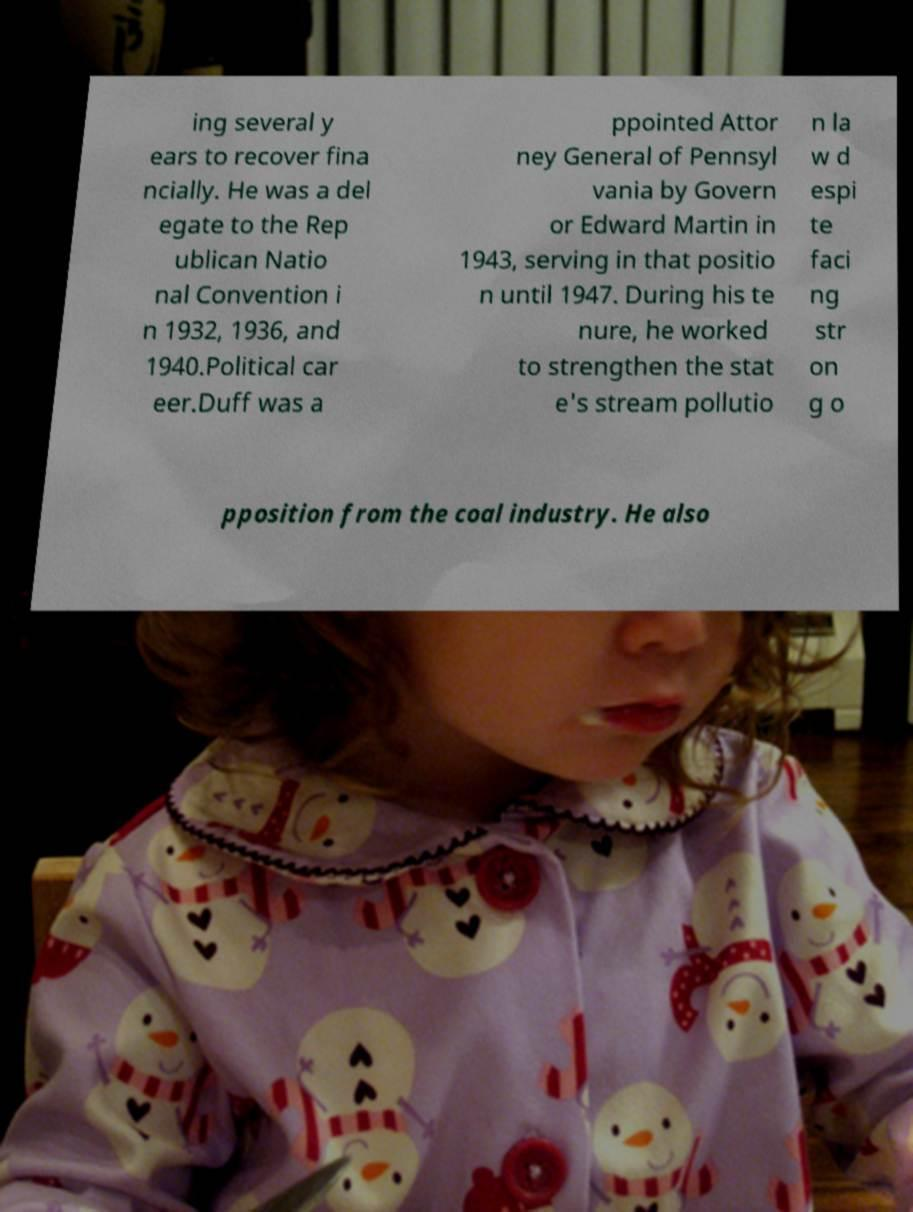There's text embedded in this image that I need extracted. Can you transcribe it verbatim? ing several y ears to recover fina ncially. He was a del egate to the Rep ublican Natio nal Convention i n 1932, 1936, and 1940.Political car eer.Duff was a ppointed Attor ney General of Pennsyl vania by Govern or Edward Martin in 1943, serving in that positio n until 1947. During his te nure, he worked to strengthen the stat e's stream pollutio n la w d espi te faci ng str on g o pposition from the coal industry. He also 